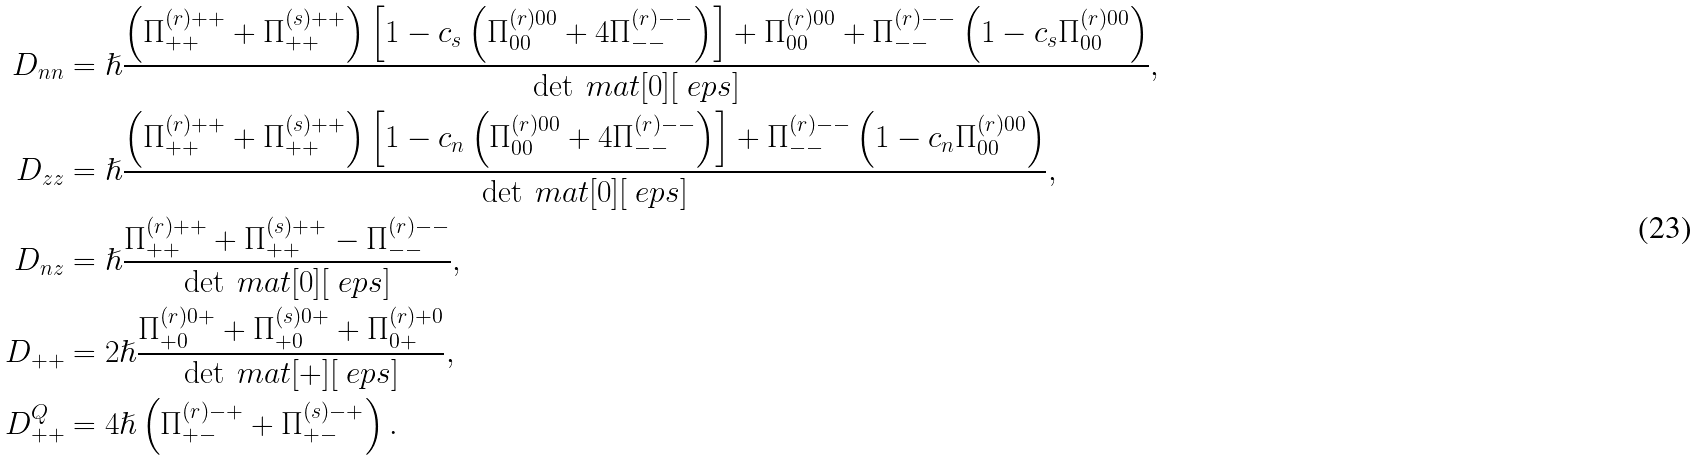<formula> <loc_0><loc_0><loc_500><loc_500>D _ { n n } & = \hslash \frac { \left ( \Pi ^ { ( r ) + + } _ { + + } + \Pi ^ { ( s ) + + } _ { + + } \right ) \left [ 1 - c _ { s } \left ( \Pi ^ { ( r ) 0 0 } _ { 0 0 } + 4 \Pi ^ { ( r ) - - } _ { - - } \right ) \right ] + \Pi ^ { ( r ) 0 0 } _ { 0 0 } + \Pi ^ { ( r ) - - } _ { - - } \left ( 1 - c _ { s } \Pi ^ { ( r ) 0 0 } _ { 0 0 } \right ) } { \det \ m a t [ 0 ] [ \ e p s ] } , \\ D _ { z z } & = \hslash \frac { \left ( \Pi ^ { ( r ) + + } _ { + + } + \Pi ^ { ( s ) + + } _ { + + } \right ) \left [ 1 - c _ { n } \left ( \Pi ^ { ( r ) 0 0 } _ { 0 0 } + 4 \Pi ^ { ( r ) - - } _ { - - } \right ) \right ] + \Pi ^ { ( r ) - - } _ { - - } \left ( 1 - c _ { n } \Pi ^ { ( r ) 0 0 } _ { 0 0 } \right ) } { \det \ m a t [ 0 ] [ \ e p s ] } , \\ D _ { n z } & = \hslash \frac { \Pi ^ { ( r ) + + } _ { + + } + \Pi ^ { ( s ) + + } _ { + + } - \Pi ^ { ( r ) - - } _ { - - } } { \det \ m a t [ 0 ] [ \ e p s ] } , \\ D _ { + + } & = 2 \hslash \frac { \Pi ^ { ( r ) 0 + } _ { + 0 } + \Pi ^ { ( s ) 0 + } _ { + 0 } + \Pi ^ { ( r ) + 0 } _ { 0 + } } { \det \ m a t [ + ] [ \ e p s ] } , \\ D ^ { Q } _ { + + } & = 4 \hslash \left ( \Pi ^ { ( r ) - + } _ { + - } + \Pi ^ { ( s ) - + } _ { + - } \right ) .</formula> 